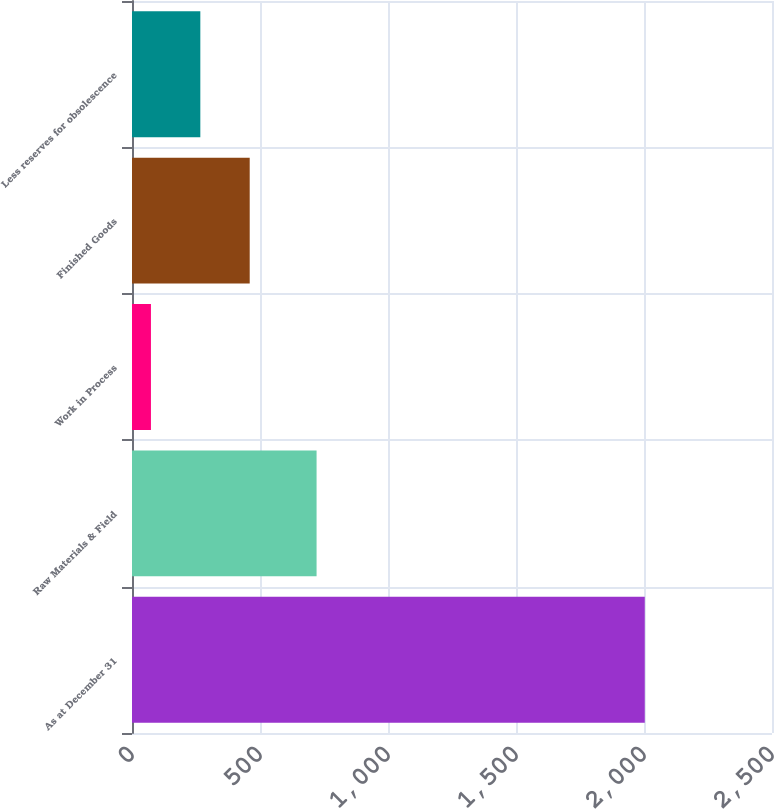<chart> <loc_0><loc_0><loc_500><loc_500><bar_chart><fcel>As at December 31<fcel>Raw Materials & Field<fcel>Work in Process<fcel>Finished Goods<fcel>Less reserves for obsolescence<nl><fcel>2003<fcel>721<fcel>74<fcel>459.8<fcel>266.9<nl></chart> 